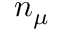Convert formula to latex. <formula><loc_0><loc_0><loc_500><loc_500>n _ { \boldsymbol \mu }</formula> 